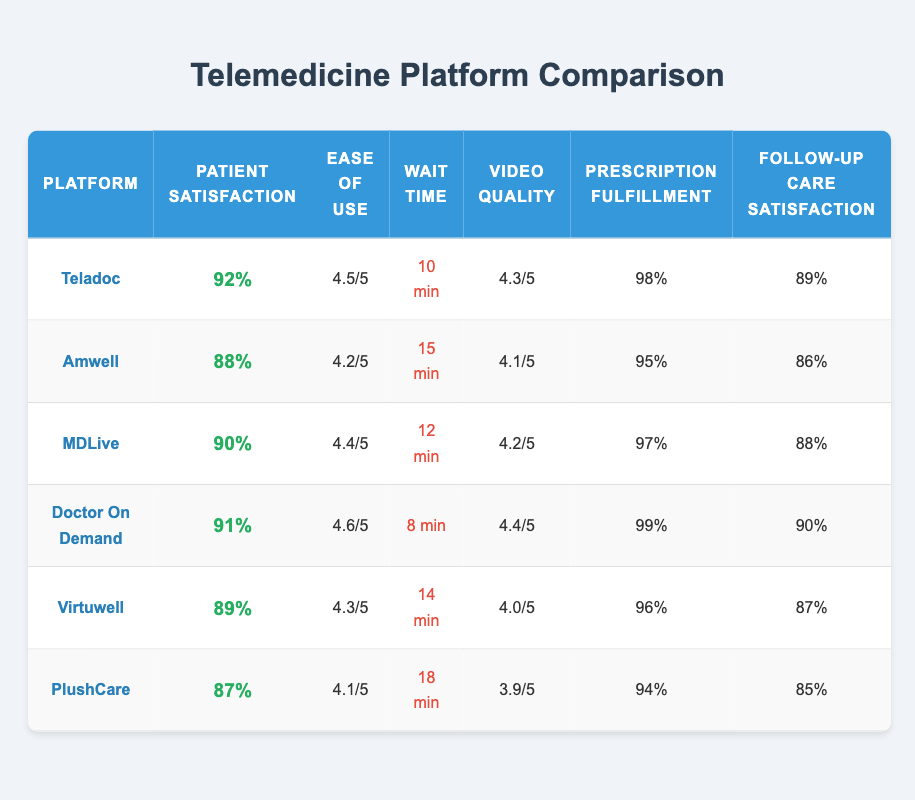What is the patient satisfaction rate for Doctor On Demand? The table shows the patient satisfaction rate for Doctor On Demand as 91%.
Answer: 91% Which telemedicine platform has the shortest wait time? According to the table, Doctor On Demand has the shortest wait time of 8 minutes.
Answer: 8 minutes What is the average patient satisfaction rate for the platforms listed? To find the average, we sum the patient satisfaction rates: (92 + 88 + 90 + 91 + 89 + 87) = 517. There are 6 platforms, so the average is 517/6 ≈ 86.17%.
Answer: 86.17% Is the prescription fulfillment rate for Teladoc higher than that of Amwell? Yes, Teladoc's prescription fulfillment rate is 98%, while Amwell's is 95%.
Answer: Yes Which platform has the highest ease of use score and what is that score? The highest ease of use score is for Doctor On Demand, which has a score of 4.6 out of 5.
Answer: 4.6 How does MDLive's follow-up care satisfaction compare to that of Virtuwell? MDLive's follow-up care satisfaction is 88%, while Virtuwell's is 87%. MDLive has a higher satisfaction rate by 1%.
Answer: MDLive is higher by 1% What is the difference in patient satisfaction rates between the highest and lowest rated platforms? Teladoc has the highest patient satisfaction rate at 92%, and PlushCare has the lowest at 87%. The difference is 92 - 87 = 5%.
Answer: 5% What percentage of patients are satisfied with the telemedicine platforms with an ease of use score of 4.2 or greater? The platforms with an ease of use score of 4.2 or greater are Teladoc (92%), Amwell (88%), MDLive (90%), and Doctor On Demand (91%). Adding these gives a sum of 361%. There are 4 platforms, so the percentage of satisfied patients is 361/4 = 90.25%.
Answer: 90.25% Which telemedicine platform has both the highest prescription fulfillment rate and the highest video quality rating? Doctor On Demand has the highest prescription fulfillment rate at 99% and a video quality rating of 4.4 out of 5, which is the highest among all listed platforms.
Answer: Doctor On Demand What is the range of wait times among the platforms? The range is calculated by subtracting the lowest wait time from the highest. The highest wait time is PlushCare at 18 minutes and the lowest is Doctor On Demand at 8 minutes, giving a range of 18 - 8 = 10 minutes.
Answer: 10 minutes 